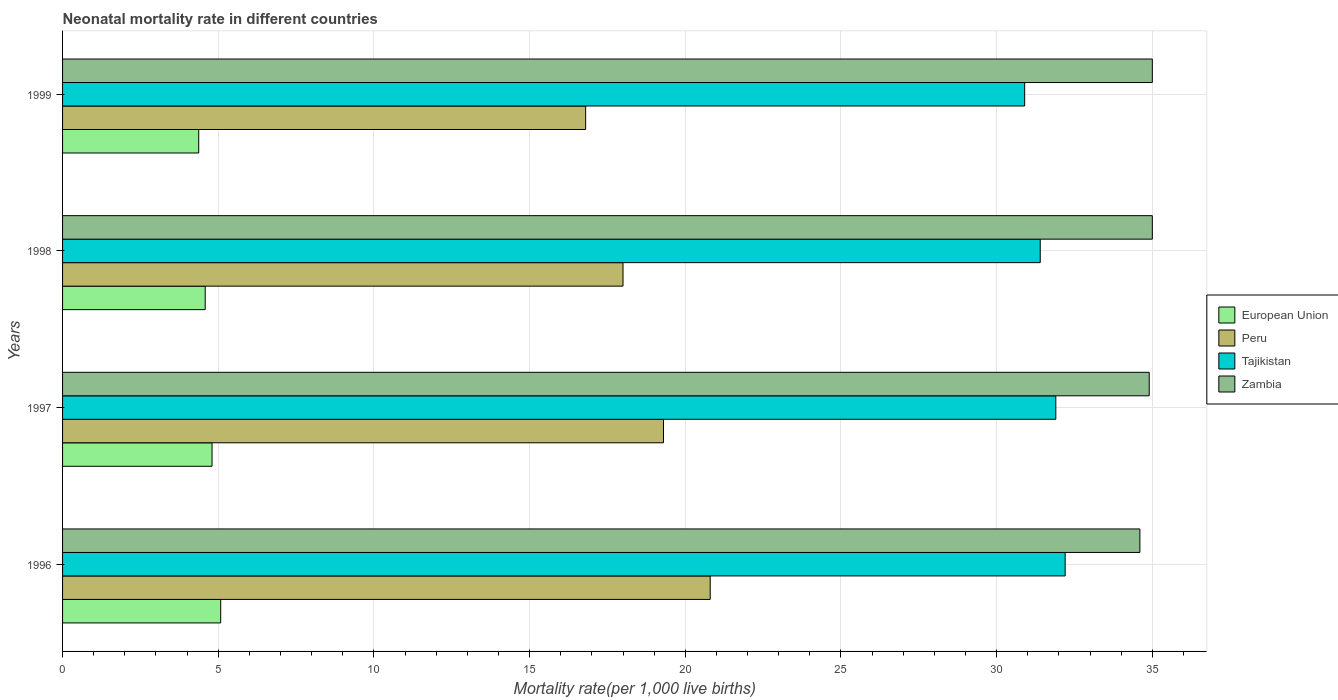How many different coloured bars are there?
Make the answer very short. 4. Are the number of bars per tick equal to the number of legend labels?
Ensure brevity in your answer.  Yes. Are the number of bars on each tick of the Y-axis equal?
Provide a short and direct response. Yes. In how many cases, is the number of bars for a given year not equal to the number of legend labels?
Keep it short and to the point. 0. What is the neonatal mortality rate in Tajikistan in 1998?
Your answer should be very brief. 31.4. Across all years, what is the maximum neonatal mortality rate in Tajikistan?
Provide a short and direct response. 32.2. In which year was the neonatal mortality rate in Peru minimum?
Provide a short and direct response. 1999. What is the total neonatal mortality rate in Peru in the graph?
Your answer should be compact. 74.9. What is the difference between the neonatal mortality rate in European Union in 1996 and that in 1998?
Provide a succinct answer. 0.5. What is the difference between the neonatal mortality rate in Tajikistan in 1997 and the neonatal mortality rate in Peru in 1998?
Offer a very short reply. 13.9. What is the average neonatal mortality rate in Zambia per year?
Provide a short and direct response. 34.88. In the year 1998, what is the difference between the neonatal mortality rate in Tajikistan and neonatal mortality rate in European Union?
Give a very brief answer. 26.82. In how many years, is the neonatal mortality rate in Peru greater than 18 ?
Your answer should be compact. 2. What is the ratio of the neonatal mortality rate in Zambia in 1997 to that in 1999?
Make the answer very short. 1. Is the neonatal mortality rate in Tajikistan in 1996 less than that in 1998?
Give a very brief answer. No. What is the difference between the highest and the second highest neonatal mortality rate in European Union?
Provide a succinct answer. 0.28. What is the difference between the highest and the lowest neonatal mortality rate in Tajikistan?
Keep it short and to the point. 1.3. Is the sum of the neonatal mortality rate in Peru in 1996 and 1998 greater than the maximum neonatal mortality rate in European Union across all years?
Your response must be concise. Yes. Is it the case that in every year, the sum of the neonatal mortality rate in Peru and neonatal mortality rate in European Union is greater than the sum of neonatal mortality rate in Zambia and neonatal mortality rate in Tajikistan?
Make the answer very short. Yes. What does the 3rd bar from the top in 1996 represents?
Your answer should be very brief. Peru. What does the 3rd bar from the bottom in 1999 represents?
Provide a short and direct response. Tajikistan. Is it the case that in every year, the sum of the neonatal mortality rate in European Union and neonatal mortality rate in Tajikistan is greater than the neonatal mortality rate in Zambia?
Your response must be concise. Yes. How many bars are there?
Keep it short and to the point. 16. Are all the bars in the graph horizontal?
Offer a very short reply. Yes. What is the difference between two consecutive major ticks on the X-axis?
Provide a short and direct response. 5. Does the graph contain grids?
Ensure brevity in your answer.  Yes. What is the title of the graph?
Ensure brevity in your answer.  Neonatal mortality rate in different countries. Does "Guatemala" appear as one of the legend labels in the graph?
Your answer should be compact. No. What is the label or title of the X-axis?
Keep it short and to the point. Mortality rate(per 1,0 live births). What is the label or title of the Y-axis?
Provide a succinct answer. Years. What is the Mortality rate(per 1,000 live births) of European Union in 1996?
Provide a succinct answer. 5.08. What is the Mortality rate(per 1,000 live births) in Peru in 1996?
Keep it short and to the point. 20.8. What is the Mortality rate(per 1,000 live births) of Tajikistan in 1996?
Give a very brief answer. 32.2. What is the Mortality rate(per 1,000 live births) in Zambia in 1996?
Your answer should be compact. 34.6. What is the Mortality rate(per 1,000 live births) in European Union in 1997?
Make the answer very short. 4.8. What is the Mortality rate(per 1,000 live births) in Peru in 1997?
Give a very brief answer. 19.3. What is the Mortality rate(per 1,000 live births) in Tajikistan in 1997?
Ensure brevity in your answer.  31.9. What is the Mortality rate(per 1,000 live births) in Zambia in 1997?
Provide a short and direct response. 34.9. What is the Mortality rate(per 1,000 live births) in European Union in 1998?
Ensure brevity in your answer.  4.58. What is the Mortality rate(per 1,000 live births) in Peru in 1998?
Ensure brevity in your answer.  18. What is the Mortality rate(per 1,000 live births) in Tajikistan in 1998?
Keep it short and to the point. 31.4. What is the Mortality rate(per 1,000 live births) of Zambia in 1998?
Your response must be concise. 35. What is the Mortality rate(per 1,000 live births) in European Union in 1999?
Offer a terse response. 4.37. What is the Mortality rate(per 1,000 live births) of Tajikistan in 1999?
Give a very brief answer. 30.9. Across all years, what is the maximum Mortality rate(per 1,000 live births) in European Union?
Your answer should be compact. 5.08. Across all years, what is the maximum Mortality rate(per 1,000 live births) of Peru?
Your response must be concise. 20.8. Across all years, what is the maximum Mortality rate(per 1,000 live births) of Tajikistan?
Provide a short and direct response. 32.2. Across all years, what is the maximum Mortality rate(per 1,000 live births) of Zambia?
Offer a terse response. 35. Across all years, what is the minimum Mortality rate(per 1,000 live births) of European Union?
Your response must be concise. 4.37. Across all years, what is the minimum Mortality rate(per 1,000 live births) in Peru?
Provide a short and direct response. 16.8. Across all years, what is the minimum Mortality rate(per 1,000 live births) of Tajikistan?
Give a very brief answer. 30.9. Across all years, what is the minimum Mortality rate(per 1,000 live births) of Zambia?
Ensure brevity in your answer.  34.6. What is the total Mortality rate(per 1,000 live births) of European Union in the graph?
Offer a very short reply. 18.83. What is the total Mortality rate(per 1,000 live births) of Peru in the graph?
Your answer should be compact. 74.9. What is the total Mortality rate(per 1,000 live births) in Tajikistan in the graph?
Your answer should be compact. 126.4. What is the total Mortality rate(per 1,000 live births) in Zambia in the graph?
Keep it short and to the point. 139.5. What is the difference between the Mortality rate(per 1,000 live births) of European Union in 1996 and that in 1997?
Make the answer very short. 0.28. What is the difference between the Mortality rate(per 1,000 live births) in Peru in 1996 and that in 1997?
Offer a terse response. 1.5. What is the difference between the Mortality rate(per 1,000 live births) in Tajikistan in 1996 and that in 1997?
Your response must be concise. 0.3. What is the difference between the Mortality rate(per 1,000 live births) of European Union in 1996 and that in 1998?
Give a very brief answer. 0.5. What is the difference between the Mortality rate(per 1,000 live births) of Peru in 1996 and that in 1998?
Offer a very short reply. 2.8. What is the difference between the Mortality rate(per 1,000 live births) in Tajikistan in 1996 and that in 1998?
Make the answer very short. 0.8. What is the difference between the Mortality rate(per 1,000 live births) in Zambia in 1996 and that in 1998?
Offer a very short reply. -0.4. What is the difference between the Mortality rate(per 1,000 live births) of European Union in 1996 and that in 1999?
Your answer should be very brief. 0.71. What is the difference between the Mortality rate(per 1,000 live births) in Tajikistan in 1996 and that in 1999?
Keep it short and to the point. 1.3. What is the difference between the Mortality rate(per 1,000 live births) in Zambia in 1996 and that in 1999?
Offer a terse response. -0.4. What is the difference between the Mortality rate(per 1,000 live births) in European Union in 1997 and that in 1998?
Your response must be concise. 0.22. What is the difference between the Mortality rate(per 1,000 live births) in Zambia in 1997 and that in 1998?
Provide a succinct answer. -0.1. What is the difference between the Mortality rate(per 1,000 live births) of European Union in 1997 and that in 1999?
Provide a short and direct response. 0.43. What is the difference between the Mortality rate(per 1,000 live births) in Zambia in 1997 and that in 1999?
Keep it short and to the point. -0.1. What is the difference between the Mortality rate(per 1,000 live births) in European Union in 1998 and that in 1999?
Provide a succinct answer. 0.21. What is the difference between the Mortality rate(per 1,000 live births) in Tajikistan in 1998 and that in 1999?
Provide a short and direct response. 0.5. What is the difference between the Mortality rate(per 1,000 live births) in European Union in 1996 and the Mortality rate(per 1,000 live births) in Peru in 1997?
Your response must be concise. -14.22. What is the difference between the Mortality rate(per 1,000 live births) of European Union in 1996 and the Mortality rate(per 1,000 live births) of Tajikistan in 1997?
Offer a very short reply. -26.82. What is the difference between the Mortality rate(per 1,000 live births) of European Union in 1996 and the Mortality rate(per 1,000 live births) of Zambia in 1997?
Offer a very short reply. -29.82. What is the difference between the Mortality rate(per 1,000 live births) in Peru in 1996 and the Mortality rate(per 1,000 live births) in Zambia in 1997?
Make the answer very short. -14.1. What is the difference between the Mortality rate(per 1,000 live births) of Tajikistan in 1996 and the Mortality rate(per 1,000 live births) of Zambia in 1997?
Provide a short and direct response. -2.7. What is the difference between the Mortality rate(per 1,000 live births) of European Union in 1996 and the Mortality rate(per 1,000 live births) of Peru in 1998?
Give a very brief answer. -12.92. What is the difference between the Mortality rate(per 1,000 live births) in European Union in 1996 and the Mortality rate(per 1,000 live births) in Tajikistan in 1998?
Provide a short and direct response. -26.32. What is the difference between the Mortality rate(per 1,000 live births) of European Union in 1996 and the Mortality rate(per 1,000 live births) of Zambia in 1998?
Your answer should be compact. -29.92. What is the difference between the Mortality rate(per 1,000 live births) of European Union in 1996 and the Mortality rate(per 1,000 live births) of Peru in 1999?
Your response must be concise. -11.72. What is the difference between the Mortality rate(per 1,000 live births) in European Union in 1996 and the Mortality rate(per 1,000 live births) in Tajikistan in 1999?
Offer a terse response. -25.82. What is the difference between the Mortality rate(per 1,000 live births) of European Union in 1996 and the Mortality rate(per 1,000 live births) of Zambia in 1999?
Keep it short and to the point. -29.92. What is the difference between the Mortality rate(per 1,000 live births) of Peru in 1996 and the Mortality rate(per 1,000 live births) of Tajikistan in 1999?
Your answer should be very brief. -10.1. What is the difference between the Mortality rate(per 1,000 live births) of European Union in 1997 and the Mortality rate(per 1,000 live births) of Peru in 1998?
Offer a very short reply. -13.2. What is the difference between the Mortality rate(per 1,000 live births) in European Union in 1997 and the Mortality rate(per 1,000 live births) in Tajikistan in 1998?
Keep it short and to the point. -26.6. What is the difference between the Mortality rate(per 1,000 live births) in European Union in 1997 and the Mortality rate(per 1,000 live births) in Zambia in 1998?
Make the answer very short. -30.2. What is the difference between the Mortality rate(per 1,000 live births) in Peru in 1997 and the Mortality rate(per 1,000 live births) in Tajikistan in 1998?
Provide a short and direct response. -12.1. What is the difference between the Mortality rate(per 1,000 live births) of Peru in 1997 and the Mortality rate(per 1,000 live births) of Zambia in 1998?
Provide a short and direct response. -15.7. What is the difference between the Mortality rate(per 1,000 live births) of Tajikistan in 1997 and the Mortality rate(per 1,000 live births) of Zambia in 1998?
Offer a very short reply. -3.1. What is the difference between the Mortality rate(per 1,000 live births) of European Union in 1997 and the Mortality rate(per 1,000 live births) of Peru in 1999?
Make the answer very short. -12. What is the difference between the Mortality rate(per 1,000 live births) in European Union in 1997 and the Mortality rate(per 1,000 live births) in Tajikistan in 1999?
Ensure brevity in your answer.  -26.1. What is the difference between the Mortality rate(per 1,000 live births) of European Union in 1997 and the Mortality rate(per 1,000 live births) of Zambia in 1999?
Offer a very short reply. -30.2. What is the difference between the Mortality rate(per 1,000 live births) in Peru in 1997 and the Mortality rate(per 1,000 live births) in Tajikistan in 1999?
Your answer should be very brief. -11.6. What is the difference between the Mortality rate(per 1,000 live births) of Peru in 1997 and the Mortality rate(per 1,000 live births) of Zambia in 1999?
Make the answer very short. -15.7. What is the difference between the Mortality rate(per 1,000 live births) in Tajikistan in 1997 and the Mortality rate(per 1,000 live births) in Zambia in 1999?
Your answer should be compact. -3.1. What is the difference between the Mortality rate(per 1,000 live births) of European Union in 1998 and the Mortality rate(per 1,000 live births) of Peru in 1999?
Keep it short and to the point. -12.22. What is the difference between the Mortality rate(per 1,000 live births) of European Union in 1998 and the Mortality rate(per 1,000 live births) of Tajikistan in 1999?
Give a very brief answer. -26.32. What is the difference between the Mortality rate(per 1,000 live births) in European Union in 1998 and the Mortality rate(per 1,000 live births) in Zambia in 1999?
Your response must be concise. -30.42. What is the difference between the Mortality rate(per 1,000 live births) in Peru in 1998 and the Mortality rate(per 1,000 live births) in Tajikistan in 1999?
Offer a terse response. -12.9. What is the difference between the Mortality rate(per 1,000 live births) in Peru in 1998 and the Mortality rate(per 1,000 live births) in Zambia in 1999?
Provide a short and direct response. -17. What is the difference between the Mortality rate(per 1,000 live births) in Tajikistan in 1998 and the Mortality rate(per 1,000 live births) in Zambia in 1999?
Your answer should be compact. -3.6. What is the average Mortality rate(per 1,000 live births) in European Union per year?
Your response must be concise. 4.71. What is the average Mortality rate(per 1,000 live births) of Peru per year?
Your answer should be very brief. 18.73. What is the average Mortality rate(per 1,000 live births) of Tajikistan per year?
Keep it short and to the point. 31.6. What is the average Mortality rate(per 1,000 live births) of Zambia per year?
Give a very brief answer. 34.88. In the year 1996, what is the difference between the Mortality rate(per 1,000 live births) of European Union and Mortality rate(per 1,000 live births) of Peru?
Offer a terse response. -15.72. In the year 1996, what is the difference between the Mortality rate(per 1,000 live births) in European Union and Mortality rate(per 1,000 live births) in Tajikistan?
Offer a terse response. -27.12. In the year 1996, what is the difference between the Mortality rate(per 1,000 live births) of European Union and Mortality rate(per 1,000 live births) of Zambia?
Give a very brief answer. -29.52. In the year 1996, what is the difference between the Mortality rate(per 1,000 live births) in Peru and Mortality rate(per 1,000 live births) in Zambia?
Offer a terse response. -13.8. In the year 1996, what is the difference between the Mortality rate(per 1,000 live births) in Tajikistan and Mortality rate(per 1,000 live births) in Zambia?
Ensure brevity in your answer.  -2.4. In the year 1997, what is the difference between the Mortality rate(per 1,000 live births) in European Union and Mortality rate(per 1,000 live births) in Peru?
Give a very brief answer. -14.5. In the year 1997, what is the difference between the Mortality rate(per 1,000 live births) of European Union and Mortality rate(per 1,000 live births) of Tajikistan?
Your answer should be compact. -27.1. In the year 1997, what is the difference between the Mortality rate(per 1,000 live births) of European Union and Mortality rate(per 1,000 live births) of Zambia?
Keep it short and to the point. -30.1. In the year 1997, what is the difference between the Mortality rate(per 1,000 live births) of Peru and Mortality rate(per 1,000 live births) of Tajikistan?
Keep it short and to the point. -12.6. In the year 1997, what is the difference between the Mortality rate(per 1,000 live births) in Peru and Mortality rate(per 1,000 live births) in Zambia?
Ensure brevity in your answer.  -15.6. In the year 1998, what is the difference between the Mortality rate(per 1,000 live births) in European Union and Mortality rate(per 1,000 live births) in Peru?
Ensure brevity in your answer.  -13.42. In the year 1998, what is the difference between the Mortality rate(per 1,000 live births) in European Union and Mortality rate(per 1,000 live births) in Tajikistan?
Your answer should be compact. -26.82. In the year 1998, what is the difference between the Mortality rate(per 1,000 live births) of European Union and Mortality rate(per 1,000 live births) of Zambia?
Your answer should be very brief. -30.42. In the year 1998, what is the difference between the Mortality rate(per 1,000 live births) in Tajikistan and Mortality rate(per 1,000 live births) in Zambia?
Offer a terse response. -3.6. In the year 1999, what is the difference between the Mortality rate(per 1,000 live births) of European Union and Mortality rate(per 1,000 live births) of Peru?
Your response must be concise. -12.43. In the year 1999, what is the difference between the Mortality rate(per 1,000 live births) of European Union and Mortality rate(per 1,000 live births) of Tajikistan?
Offer a very short reply. -26.53. In the year 1999, what is the difference between the Mortality rate(per 1,000 live births) in European Union and Mortality rate(per 1,000 live births) in Zambia?
Provide a succinct answer. -30.63. In the year 1999, what is the difference between the Mortality rate(per 1,000 live births) of Peru and Mortality rate(per 1,000 live births) of Tajikistan?
Your answer should be very brief. -14.1. In the year 1999, what is the difference between the Mortality rate(per 1,000 live births) in Peru and Mortality rate(per 1,000 live births) in Zambia?
Your answer should be very brief. -18.2. What is the ratio of the Mortality rate(per 1,000 live births) in European Union in 1996 to that in 1997?
Keep it short and to the point. 1.06. What is the ratio of the Mortality rate(per 1,000 live births) in Peru in 1996 to that in 1997?
Your response must be concise. 1.08. What is the ratio of the Mortality rate(per 1,000 live births) of Tajikistan in 1996 to that in 1997?
Offer a very short reply. 1.01. What is the ratio of the Mortality rate(per 1,000 live births) of Zambia in 1996 to that in 1997?
Your answer should be very brief. 0.99. What is the ratio of the Mortality rate(per 1,000 live births) in European Union in 1996 to that in 1998?
Offer a very short reply. 1.11. What is the ratio of the Mortality rate(per 1,000 live births) in Peru in 1996 to that in 1998?
Keep it short and to the point. 1.16. What is the ratio of the Mortality rate(per 1,000 live births) of Tajikistan in 1996 to that in 1998?
Your answer should be very brief. 1.03. What is the ratio of the Mortality rate(per 1,000 live births) in Zambia in 1996 to that in 1998?
Your response must be concise. 0.99. What is the ratio of the Mortality rate(per 1,000 live births) of European Union in 1996 to that in 1999?
Your answer should be very brief. 1.16. What is the ratio of the Mortality rate(per 1,000 live births) of Peru in 1996 to that in 1999?
Your response must be concise. 1.24. What is the ratio of the Mortality rate(per 1,000 live births) of Tajikistan in 1996 to that in 1999?
Provide a succinct answer. 1.04. What is the ratio of the Mortality rate(per 1,000 live births) in European Union in 1997 to that in 1998?
Your answer should be compact. 1.05. What is the ratio of the Mortality rate(per 1,000 live births) of Peru in 1997 to that in 1998?
Your response must be concise. 1.07. What is the ratio of the Mortality rate(per 1,000 live births) in Tajikistan in 1997 to that in 1998?
Provide a short and direct response. 1.02. What is the ratio of the Mortality rate(per 1,000 live births) of Zambia in 1997 to that in 1998?
Ensure brevity in your answer.  1. What is the ratio of the Mortality rate(per 1,000 live births) in European Union in 1997 to that in 1999?
Make the answer very short. 1.1. What is the ratio of the Mortality rate(per 1,000 live births) in Peru in 1997 to that in 1999?
Your response must be concise. 1.15. What is the ratio of the Mortality rate(per 1,000 live births) in Tajikistan in 1997 to that in 1999?
Your answer should be very brief. 1.03. What is the ratio of the Mortality rate(per 1,000 live births) of European Union in 1998 to that in 1999?
Offer a very short reply. 1.05. What is the ratio of the Mortality rate(per 1,000 live births) of Peru in 1998 to that in 1999?
Your answer should be very brief. 1.07. What is the ratio of the Mortality rate(per 1,000 live births) of Tajikistan in 1998 to that in 1999?
Your response must be concise. 1.02. What is the difference between the highest and the second highest Mortality rate(per 1,000 live births) in European Union?
Offer a terse response. 0.28. What is the difference between the highest and the second highest Mortality rate(per 1,000 live births) in Peru?
Your response must be concise. 1.5. What is the difference between the highest and the lowest Mortality rate(per 1,000 live births) in European Union?
Provide a short and direct response. 0.71. What is the difference between the highest and the lowest Mortality rate(per 1,000 live births) of Tajikistan?
Provide a short and direct response. 1.3. What is the difference between the highest and the lowest Mortality rate(per 1,000 live births) of Zambia?
Your response must be concise. 0.4. 